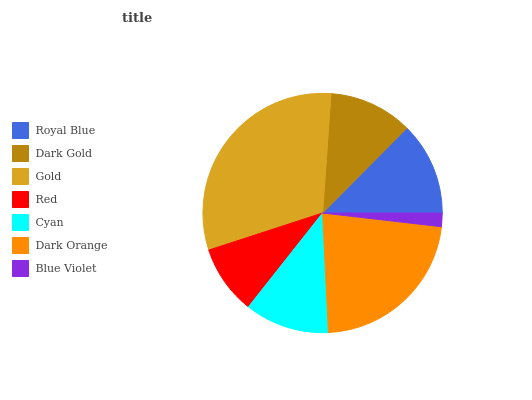Is Blue Violet the minimum?
Answer yes or no. Yes. Is Gold the maximum?
Answer yes or no. Yes. Is Dark Gold the minimum?
Answer yes or no. No. Is Dark Gold the maximum?
Answer yes or no. No. Is Royal Blue greater than Dark Gold?
Answer yes or no. Yes. Is Dark Gold less than Royal Blue?
Answer yes or no. Yes. Is Dark Gold greater than Royal Blue?
Answer yes or no. No. Is Royal Blue less than Dark Gold?
Answer yes or no. No. Is Cyan the high median?
Answer yes or no. Yes. Is Cyan the low median?
Answer yes or no. Yes. Is Gold the high median?
Answer yes or no. No. Is Dark Orange the low median?
Answer yes or no. No. 